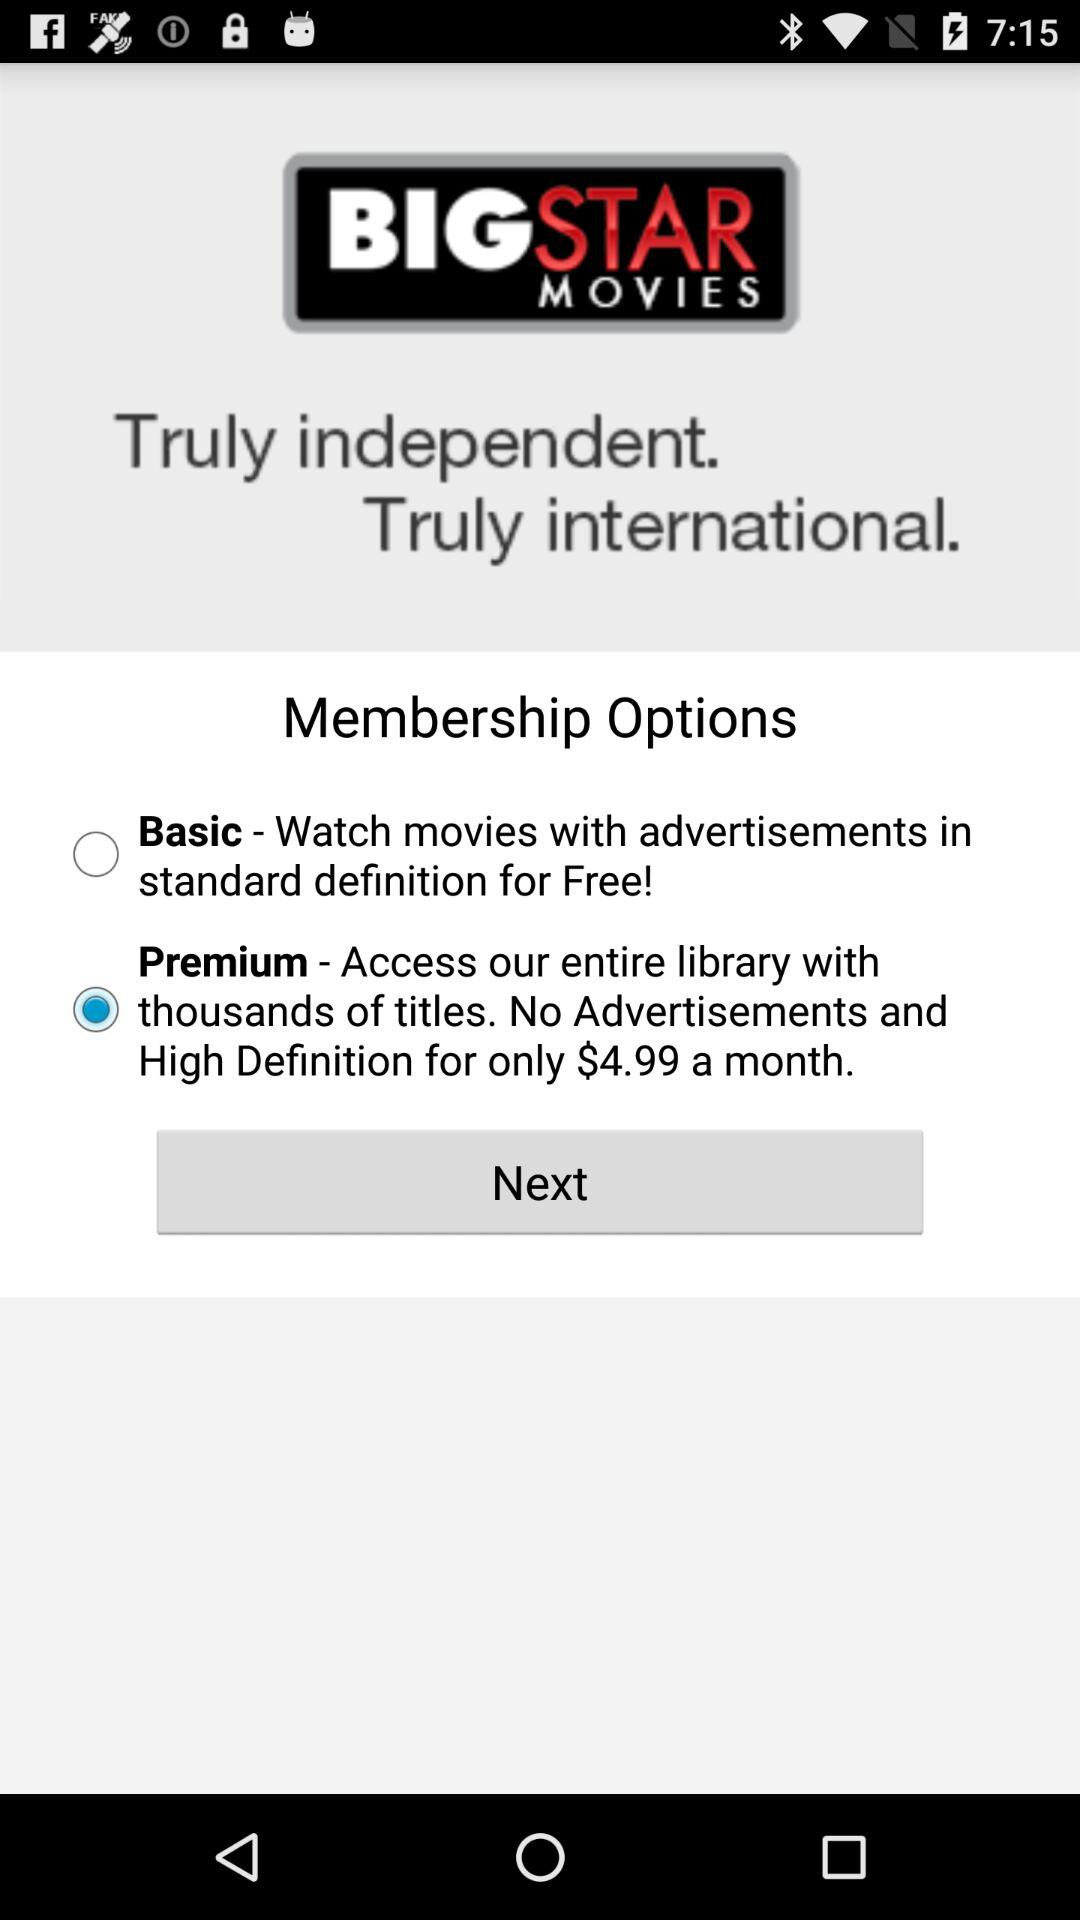Which membership option was selected? The selected membership option was "Premium". 